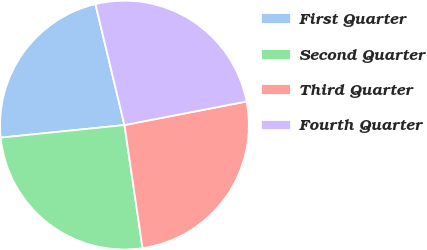Convert chart to OTSL. <chart><loc_0><loc_0><loc_500><loc_500><pie_chart><fcel>First Quarter<fcel>Second Quarter<fcel>Third Quarter<fcel>Fourth Quarter<nl><fcel>22.86%<fcel>25.71%<fcel>25.71%<fcel>25.71%<nl></chart> 